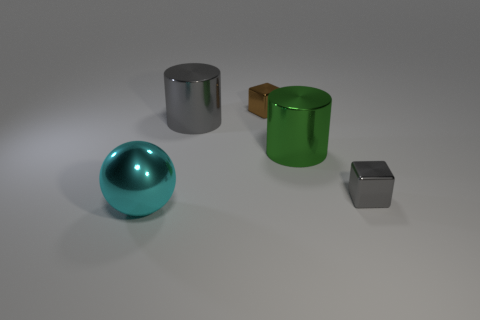Add 1 big gray matte things. How many objects exist? 6 Subtract all balls. How many objects are left? 4 Subtract 0 purple blocks. How many objects are left? 5 Subtract all big brown rubber cylinders. Subtract all brown shiny things. How many objects are left? 4 Add 2 large gray cylinders. How many large gray cylinders are left? 3 Add 4 brown objects. How many brown objects exist? 5 